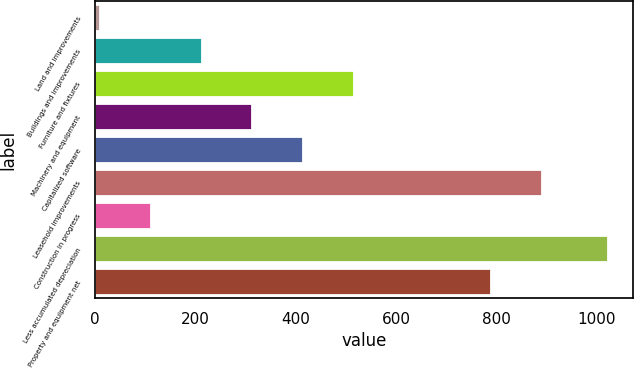Convert chart to OTSL. <chart><loc_0><loc_0><loc_500><loc_500><bar_chart><fcel>Land and improvements<fcel>Buildings and improvements<fcel>Furniture and fixtures<fcel>Machinery and equipment<fcel>Capitalized software<fcel>Leasehold improvements<fcel>Construction in progress<fcel>Less accumulated depreciation<fcel>Property and equipment net<nl><fcel>9.9<fcel>212.22<fcel>515.7<fcel>313.38<fcel>414.54<fcel>889.96<fcel>111.06<fcel>1021.5<fcel>788.8<nl></chart> 